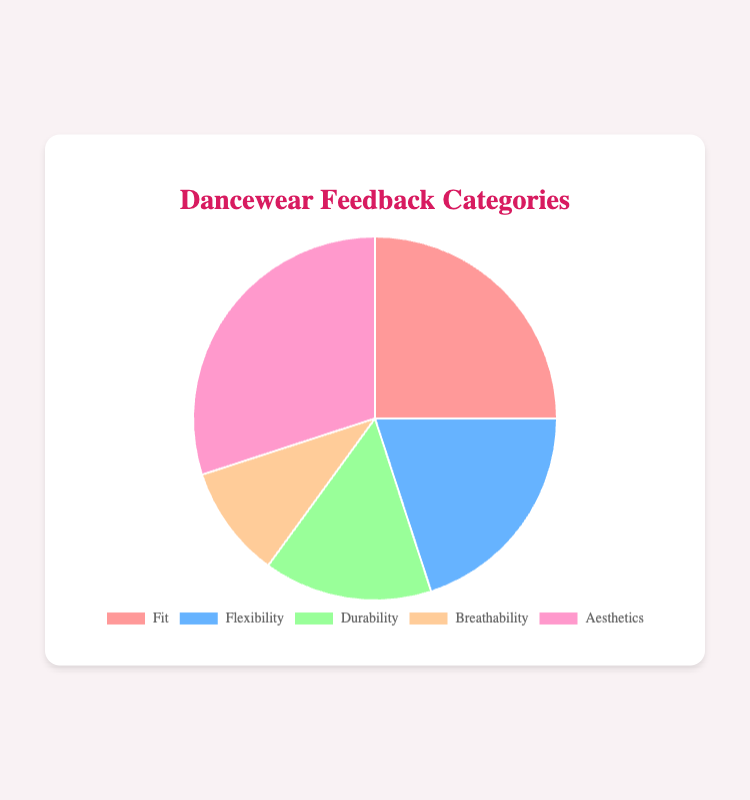Which feedback category has the highest percentage? The pie chart shows the percentages for each feedback category. By observing the data, the Aesthetics category has the highest percentage at 30%.
Answer: Aesthetics Which two feedback categories combined have the same percentage as the Aesthetics category? The Aesthetics category is 30%. Summing the percentages of Flexibility (20%) and Breathability (10%) equals 30%, which matches Aesthetics' percentage.
Answer: Flexibility and Breathability What is the difference in percentage between the Fit and Durability categories? The Fit category has 25% and the Durability category has 15%. The difference is calculated as 25% - 15% = 10%.
Answer: 10% How does the percentage of Aesthetics compare to that of Fit and Flexibility combined? Aesthetics is 30%. Fit is 25% and Flexibility is 20%. Combined, Fit and Flexibility sum to 25% + 20% = 45%, which is higher than Aesthetics' 30%.
Answer: Less than combined Fit and Flexibility What percentage is represented by the two categories with the lowest percentages? The two categories with the lowest percentages are Breathability (10%) and Durability (15%). Their combined percentage is 10% + 15% = 25%.
Answer: 25% Which category has the second highest percentage? Observing the pie chart, Fit has the second highest percentage at 25%, just below Aesthetics at 30%.
Answer: Fit If you combined the Durability and Flexibility categories, what would their total percentage be? Durability is 15% and Flexibility is 20%, so their combined total would be 15% + 20% = 35%.
Answer: 35% Is the percentage for Breathability less than half the percentage for Fit? Breathability is 10% and Fit is 25%. Half of Fit’s percentage is 25% / 2 = 12.5%. Since 10% is less than 12.5%, the percentage for Breathability is less than half of Fit.
Answer: Yes What is the average percentage of all feedback categories? Sum all the categories' percentages: 25% (Fit) + 20% (Flexibility) + 15% (Durability) + 10% (Breathability) + 30% (Aesthetics) = 100%. There are 5 categories, so the average is 100% / 5 = 20%.
Answer: 20% 